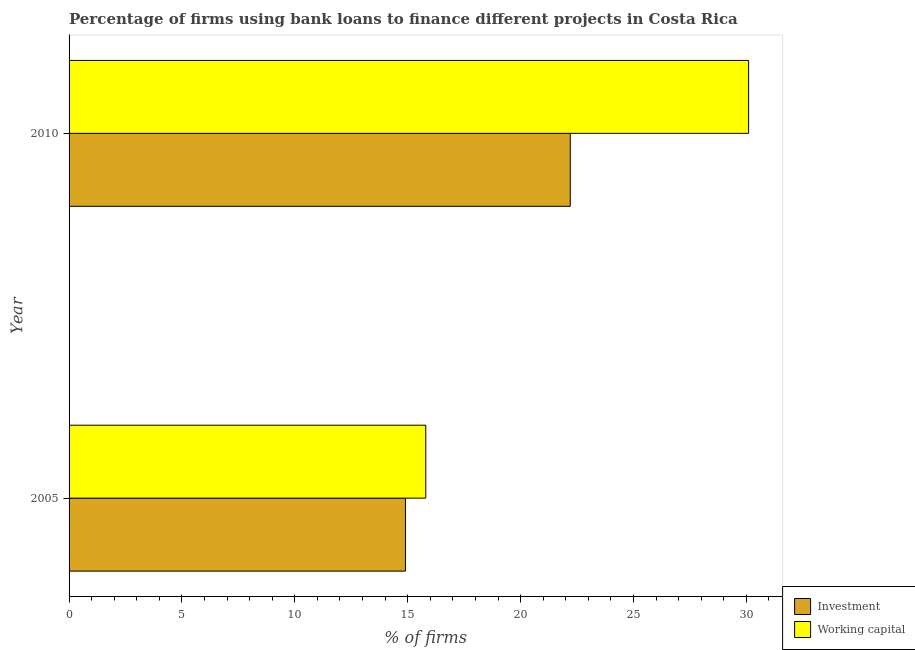How many different coloured bars are there?
Provide a short and direct response. 2. How many groups of bars are there?
Your answer should be very brief. 2. Are the number of bars on each tick of the Y-axis equal?
Offer a terse response. Yes. How many bars are there on the 1st tick from the top?
Keep it short and to the point. 2. Across all years, what is the maximum percentage of firms using banks to finance investment?
Offer a very short reply. 22.2. What is the total percentage of firms using banks to finance investment in the graph?
Offer a terse response. 37.1. What is the difference between the percentage of firms using banks to finance working capital in 2005 and that in 2010?
Provide a succinct answer. -14.3. What is the difference between the percentage of firms using banks to finance investment in 2010 and the percentage of firms using banks to finance working capital in 2005?
Provide a short and direct response. 6.4. What is the average percentage of firms using banks to finance working capital per year?
Make the answer very short. 22.95. In the year 2010, what is the difference between the percentage of firms using banks to finance working capital and percentage of firms using banks to finance investment?
Offer a terse response. 7.9. In how many years, is the percentage of firms using banks to finance working capital greater than 18 %?
Give a very brief answer. 1. What is the ratio of the percentage of firms using banks to finance investment in 2005 to that in 2010?
Offer a terse response. 0.67. What does the 1st bar from the top in 2005 represents?
Your answer should be compact. Working capital. What does the 2nd bar from the bottom in 2010 represents?
Offer a terse response. Working capital. Are all the bars in the graph horizontal?
Make the answer very short. Yes. How many years are there in the graph?
Offer a terse response. 2. How many legend labels are there?
Make the answer very short. 2. How are the legend labels stacked?
Your response must be concise. Vertical. What is the title of the graph?
Your response must be concise. Percentage of firms using bank loans to finance different projects in Costa Rica. Does "Taxes on profits and capital gains" appear as one of the legend labels in the graph?
Ensure brevity in your answer.  No. What is the label or title of the X-axis?
Provide a short and direct response. % of firms. What is the % of firms in Working capital in 2010?
Make the answer very short. 30.1. Across all years, what is the maximum % of firms of Working capital?
Offer a very short reply. 30.1. Across all years, what is the minimum % of firms of Investment?
Keep it short and to the point. 14.9. What is the total % of firms of Investment in the graph?
Your response must be concise. 37.1. What is the total % of firms of Working capital in the graph?
Make the answer very short. 45.9. What is the difference between the % of firms of Working capital in 2005 and that in 2010?
Your response must be concise. -14.3. What is the difference between the % of firms in Investment in 2005 and the % of firms in Working capital in 2010?
Give a very brief answer. -15.2. What is the average % of firms in Investment per year?
Make the answer very short. 18.55. What is the average % of firms of Working capital per year?
Offer a very short reply. 22.95. In the year 2005, what is the difference between the % of firms of Investment and % of firms of Working capital?
Provide a short and direct response. -0.9. In the year 2010, what is the difference between the % of firms of Investment and % of firms of Working capital?
Offer a terse response. -7.9. What is the ratio of the % of firms of Investment in 2005 to that in 2010?
Your answer should be compact. 0.67. What is the ratio of the % of firms in Working capital in 2005 to that in 2010?
Ensure brevity in your answer.  0.52. What is the difference between the highest and the second highest % of firms of Working capital?
Your response must be concise. 14.3. What is the difference between the highest and the lowest % of firms in Working capital?
Make the answer very short. 14.3. 